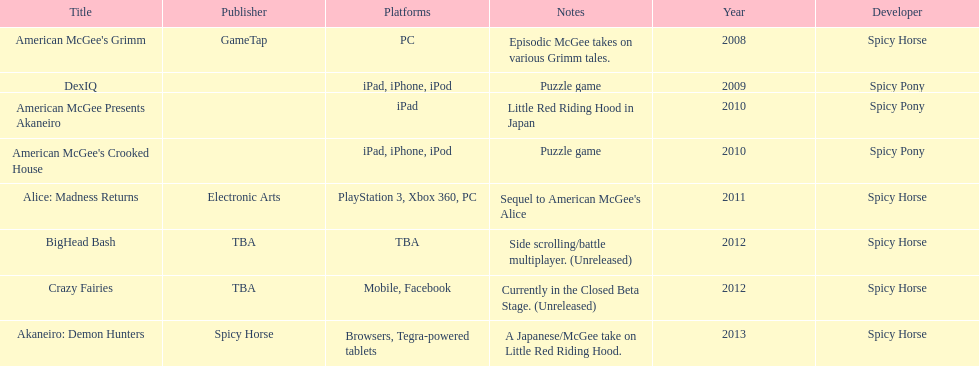According to the table, what is the last title that spicy horse produced? Akaneiro: Demon Hunters. 